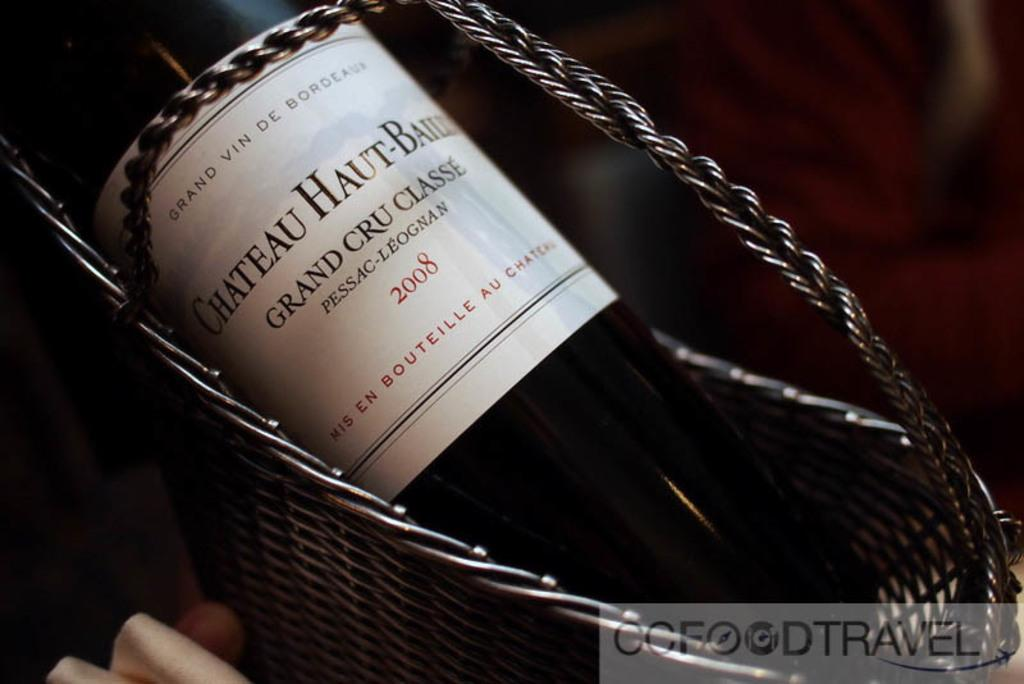<image>
Offer a succinct explanation of the picture presented. A bottle of 2008 Grand Cru Classe in a basket. 